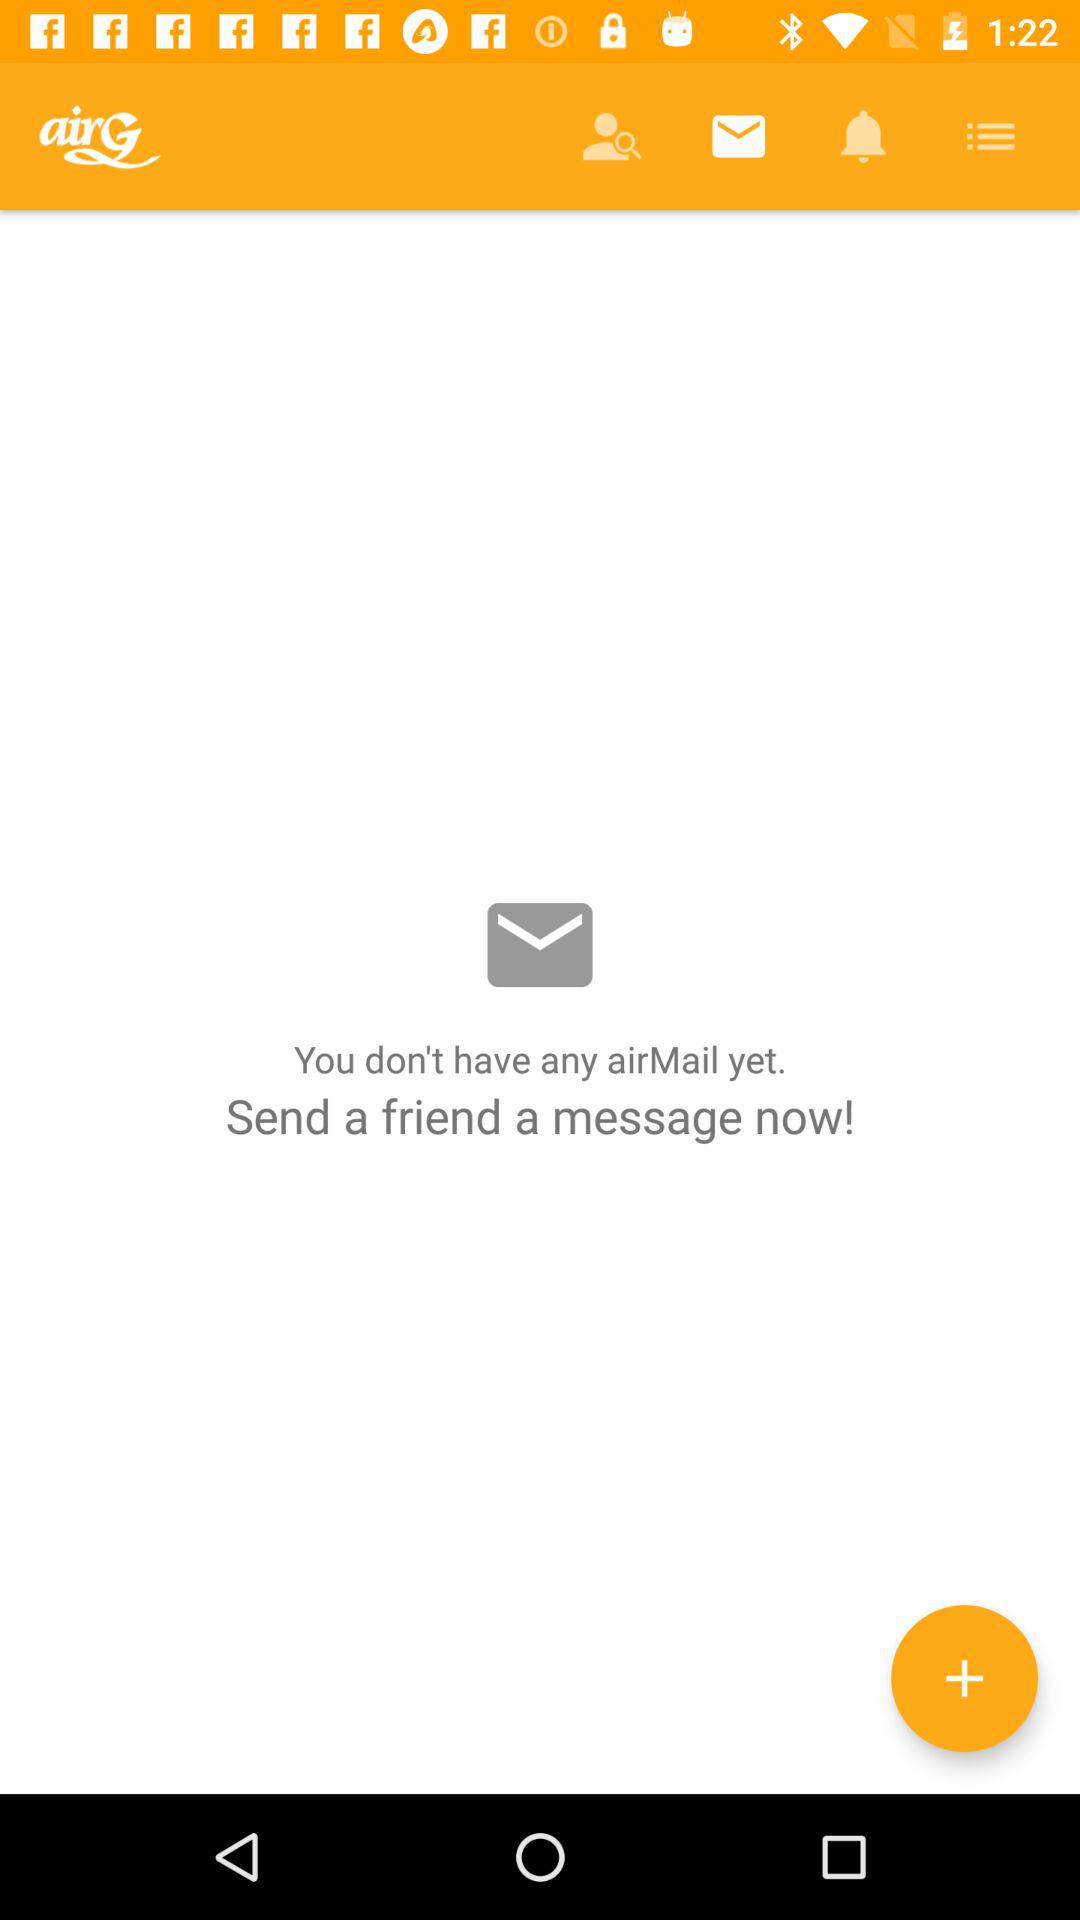What is the name of the application? The name of the application is "airG". 